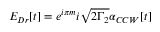<formula> <loc_0><loc_0><loc_500><loc_500>E _ { D r } [ t ] = e ^ { i \pi m } i \sqrt { 2 \Gamma _ { 2 } } \alpha _ { C C W } [ t ]</formula> 